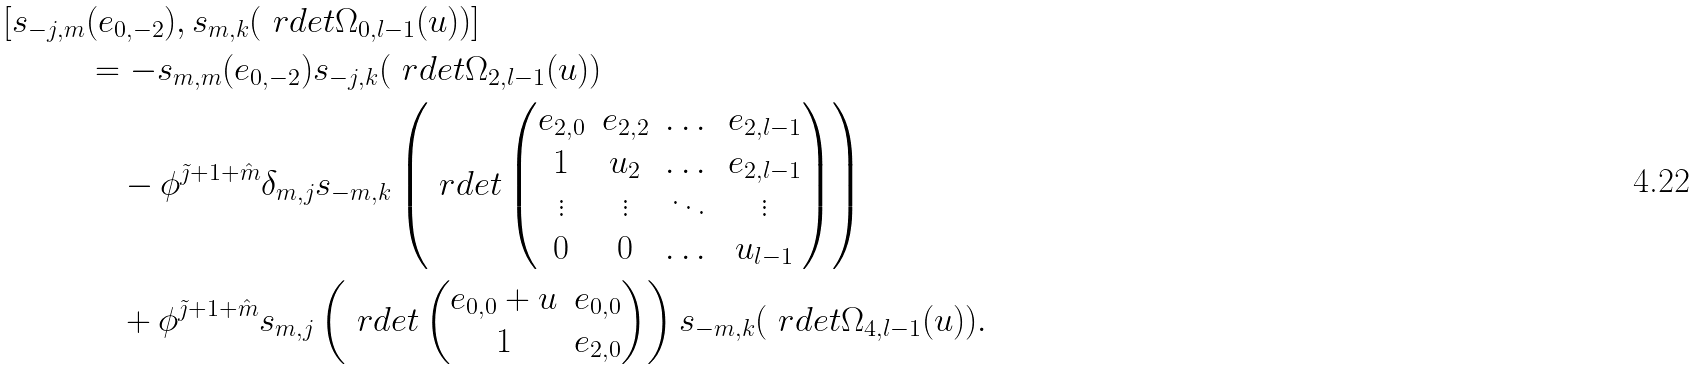Convert formula to latex. <formula><loc_0><loc_0><loc_500><loc_500>[ s _ { - j , m } & ( e _ { 0 , - 2 } ) , s _ { m , k } ( \ r d e t \Omega _ { 0 , l - 1 } ( u ) ) ] \\ & = - s _ { m , m } ( e _ { 0 , - 2 } ) s _ { - j , k } ( \ r d e t \Omega _ { 2 , l - 1 } ( u ) ) \\ & \quad - \phi ^ { \tilde { \jmath } + 1 + \hat { m } } \delta _ { m , j } s _ { - m , k } \left ( \ r d e t \begin{pmatrix} e _ { 2 , 0 } & e _ { 2 , 2 } & \dots & e _ { 2 , l - 1 } \\ 1 & u _ { 2 } & \dots & e _ { 2 , l - 1 } \\ \vdots & \vdots & \ddots & \vdots \\ 0 & 0 & \dots & u _ { l - 1 } \end{pmatrix} \right ) \\ & \quad + \phi ^ { \tilde { \jmath } + 1 + \hat { m } } s _ { m , j } \left ( \ r d e t \begin{pmatrix} e _ { 0 , 0 } + u & e _ { 0 , 0 } \\ 1 & e _ { 2 , 0 } \end{pmatrix} \right ) s _ { - m , k } ( \ r d e t \Omega _ { 4 , l - 1 } ( u ) ) .</formula> 